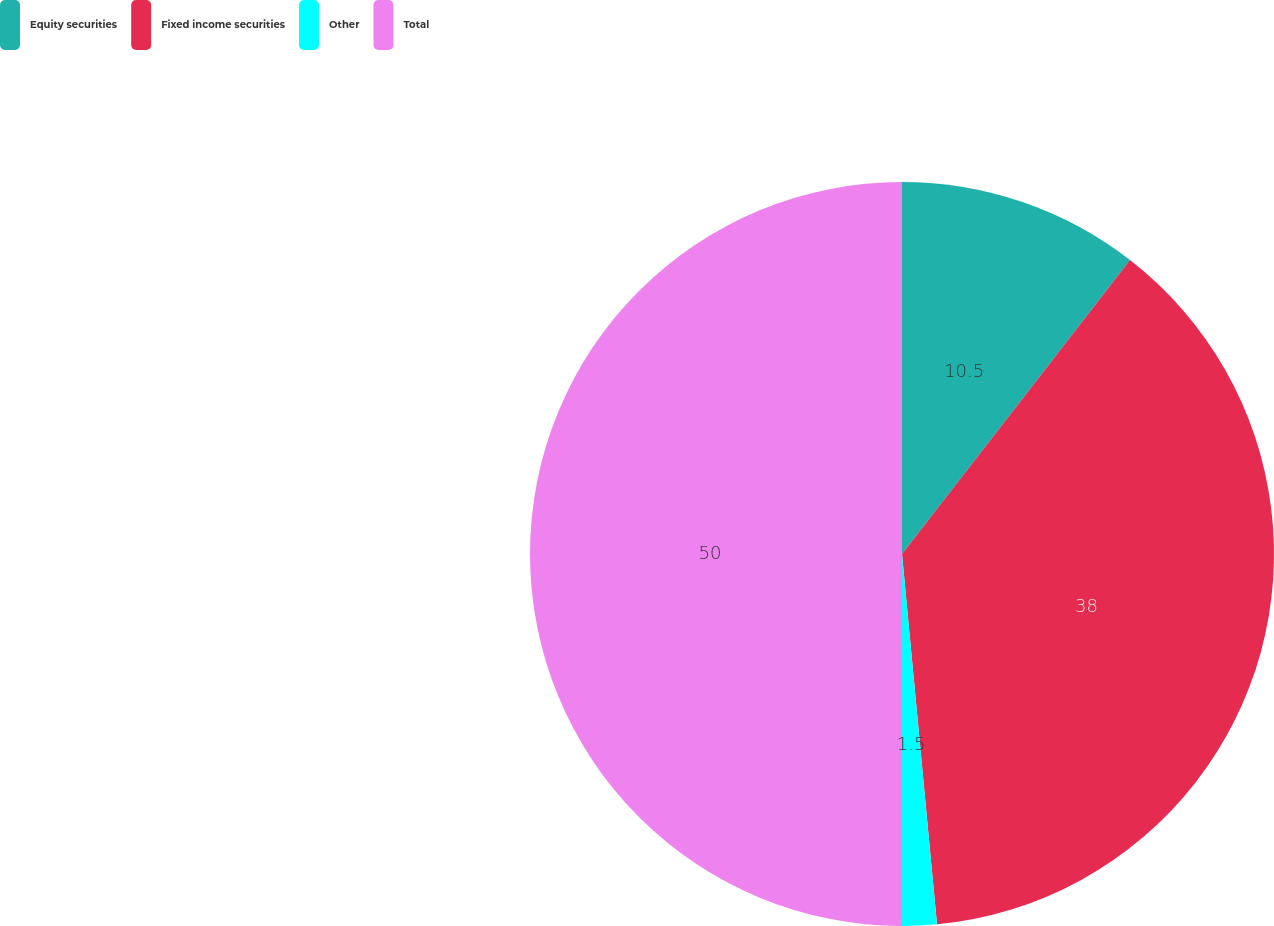<chart> <loc_0><loc_0><loc_500><loc_500><pie_chart><fcel>Equity securities<fcel>Fixed income securities<fcel>Other<fcel>Total<nl><fcel>10.5%<fcel>38.0%<fcel>1.5%<fcel>50.0%<nl></chart> 